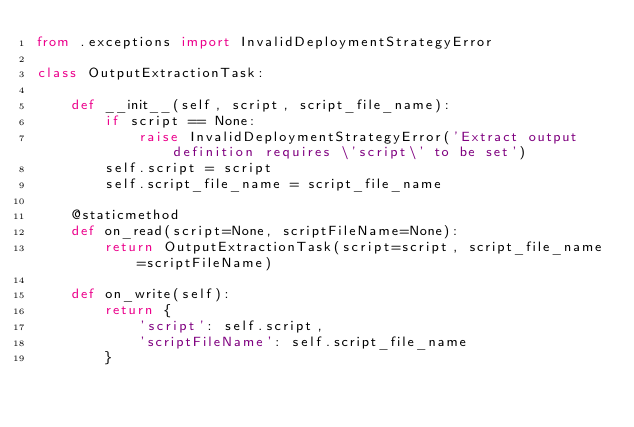Convert code to text. <code><loc_0><loc_0><loc_500><loc_500><_Python_>from .exceptions import InvalidDeploymentStrategyError

class OutputExtractionTask:

    def __init__(self, script, script_file_name):
        if script == None:
            raise InvalidDeploymentStrategyError('Extract output definition requires \'script\' to be set')
        self.script = script
        self.script_file_name = script_file_name

    @staticmethod
    def on_read(script=None, scriptFileName=None):
        return OutputExtractionTask(script=script, script_file_name=scriptFileName)

    def on_write(self):
        return {
            'script': self.script,
            'scriptFileName': self.script_file_name
        }
</code> 